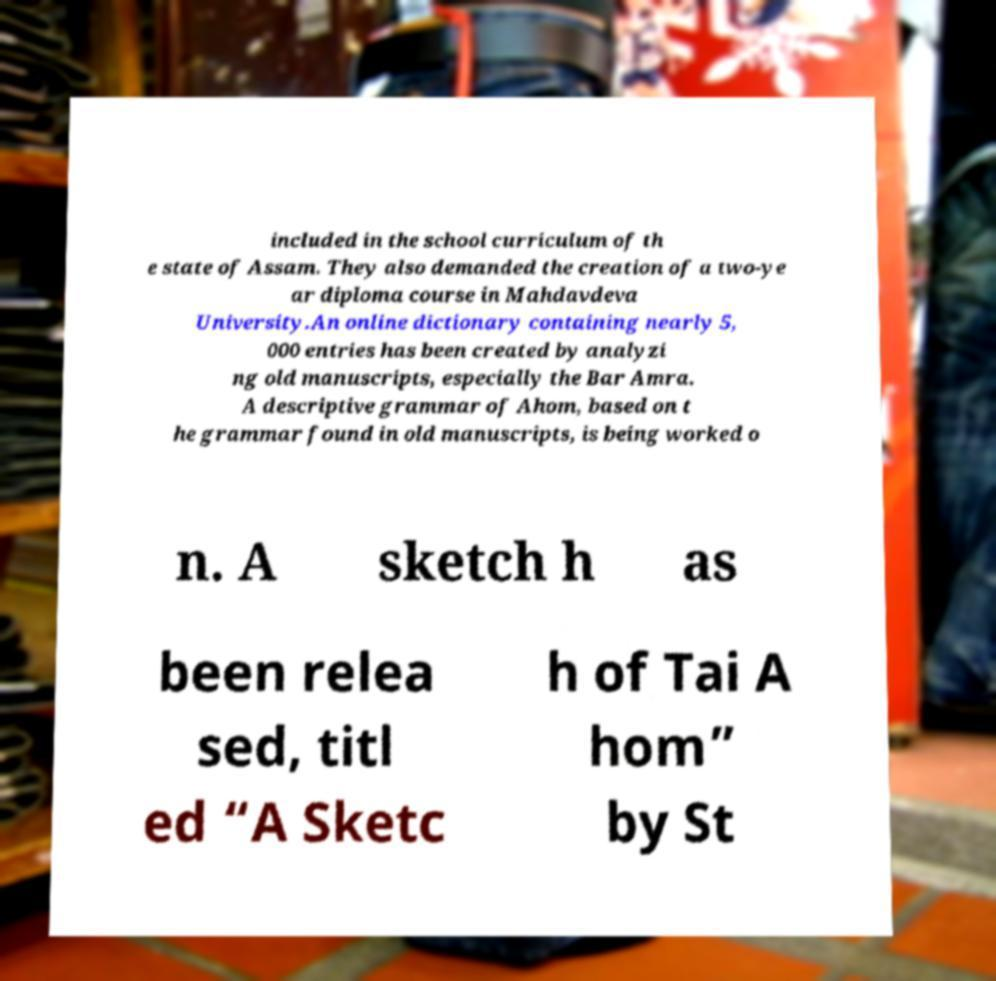For documentation purposes, I need the text within this image transcribed. Could you provide that? included in the school curriculum of th e state of Assam. They also demanded the creation of a two-ye ar diploma course in Mahdavdeva University.An online dictionary containing nearly 5, 000 entries has been created by analyzi ng old manuscripts, especially the Bar Amra. A descriptive grammar of Ahom, based on t he grammar found in old manuscripts, is being worked o n. A sketch h as been relea sed, titl ed “A Sketc h of Tai A hom” by St 